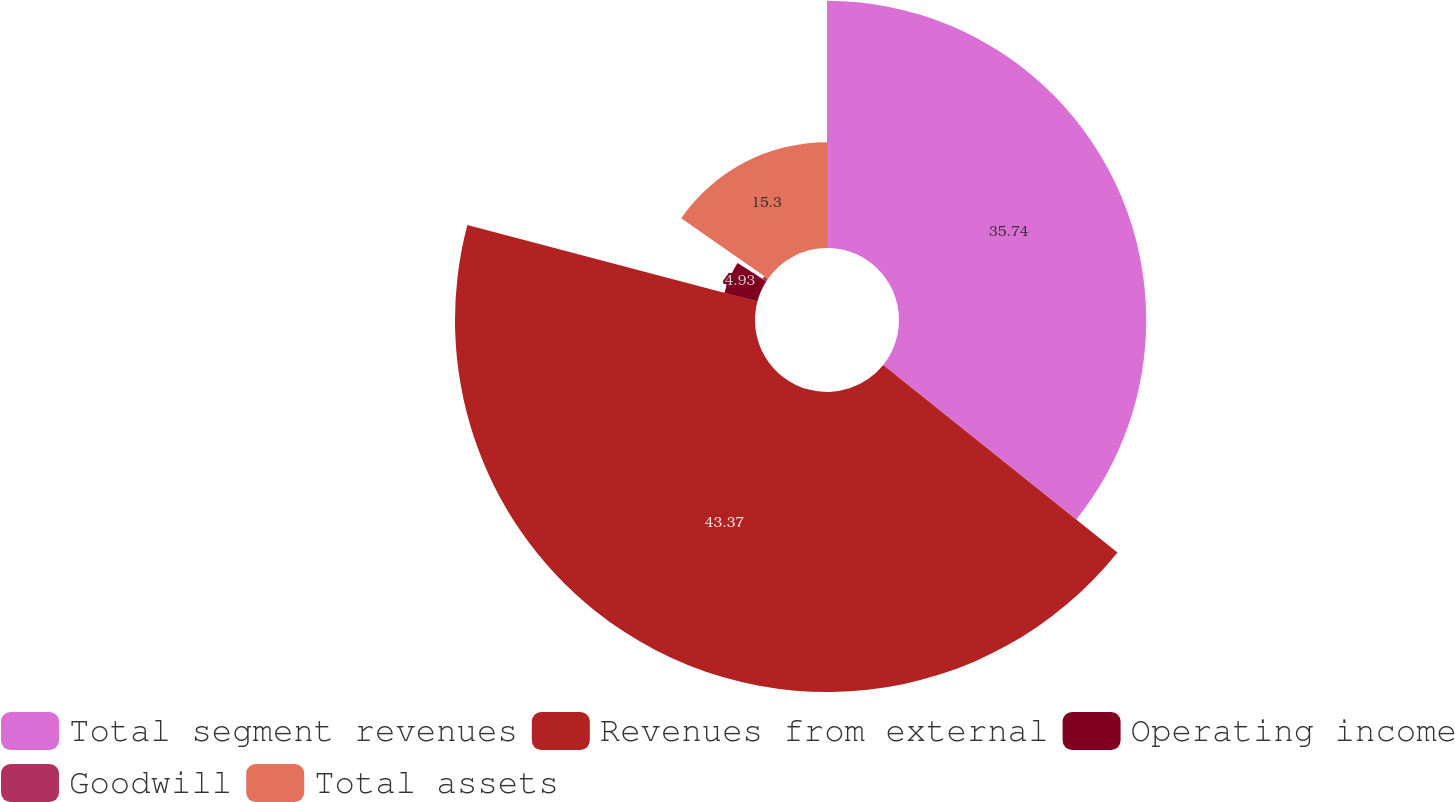Convert chart. <chart><loc_0><loc_0><loc_500><loc_500><pie_chart><fcel>Total segment revenues<fcel>Revenues from external<fcel>Operating income<fcel>Goodwill<fcel>Total assets<nl><fcel>35.74%<fcel>43.37%<fcel>4.93%<fcel>0.66%<fcel>15.3%<nl></chart> 